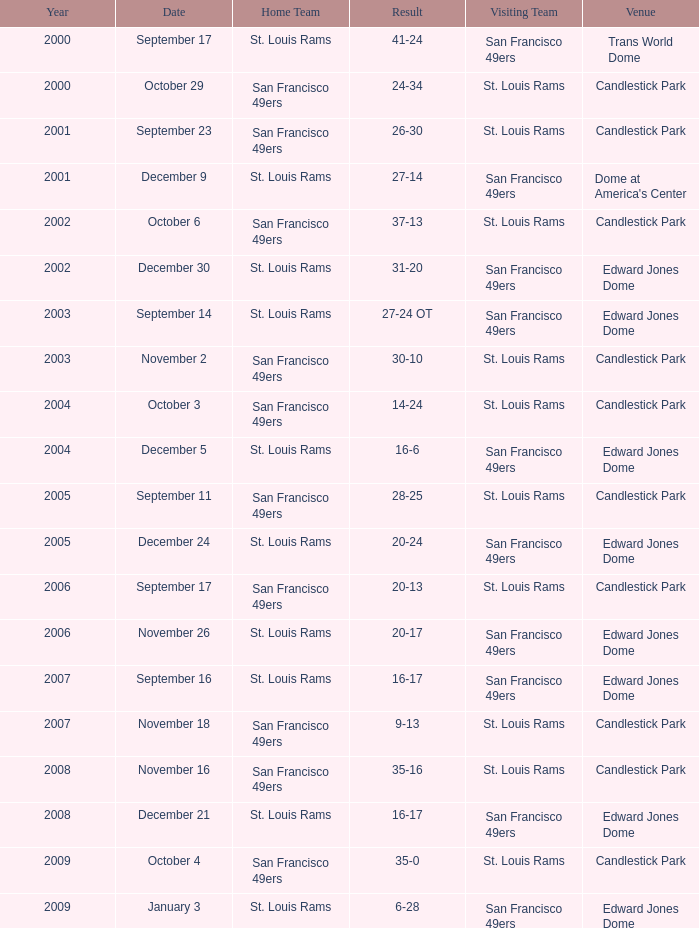What is the Venue of the 2009 St. Louis Rams Home game? Edward Jones Dome. 